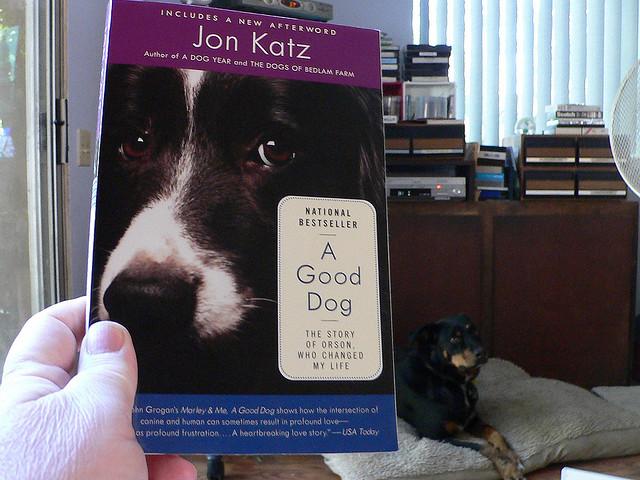Who wrote the book?
Answer briefly. Jon katz. How many dogs are pictured?
Concise answer only. 2. What breed of dog is in the photo?
Answer briefly. Rottweiler. 